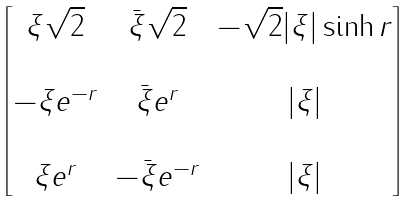Convert formula to latex. <formula><loc_0><loc_0><loc_500><loc_500>\begin{bmatrix} \xi \sqrt { 2 } & \bar { \xi } \sqrt { 2 } & - \sqrt { 2 } | \xi | \sinh r \\ & & \\ - \xi e ^ { - r } & \bar { \xi } e ^ { r } & | \xi | \\ & & \\ \xi e ^ { r } & - \bar { \xi } e ^ { - r } & | \xi | \end{bmatrix}</formula> 